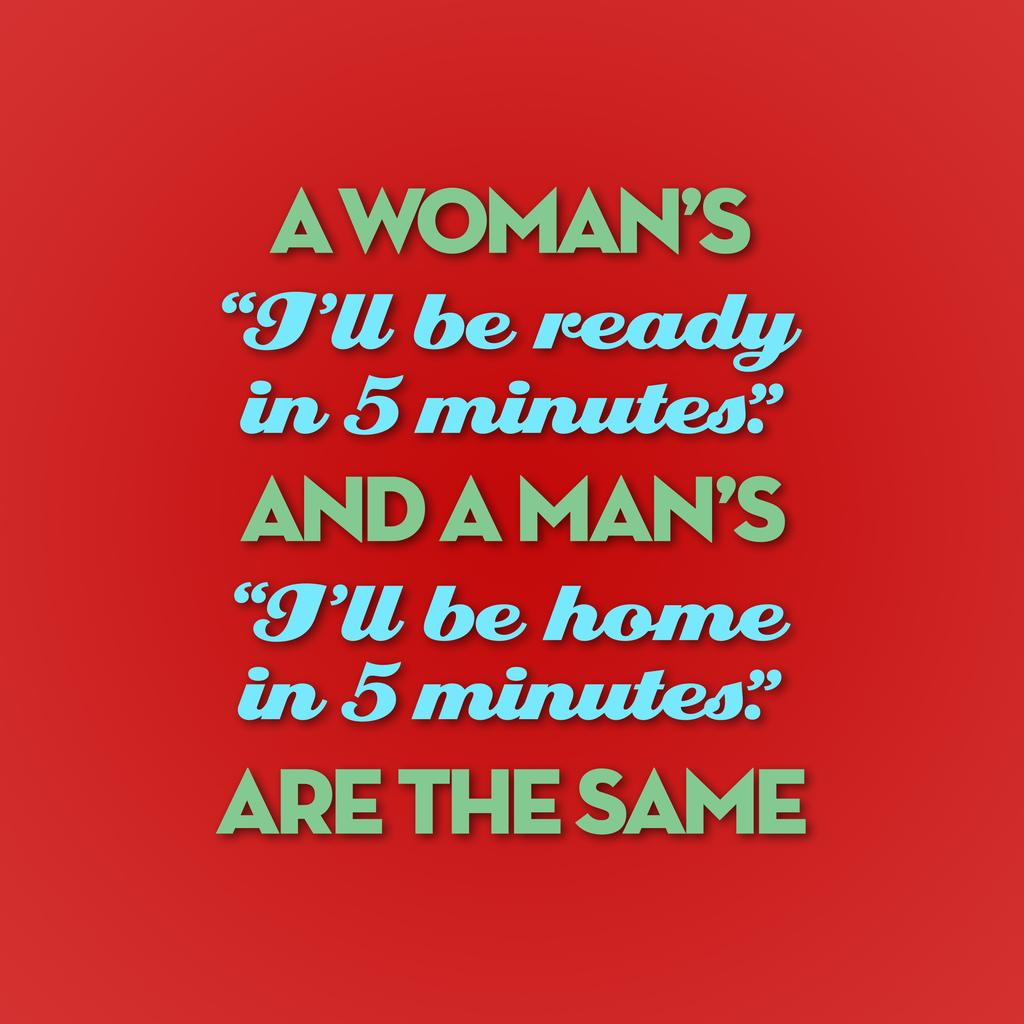<image>
Present a compact description of the photo's key features. A vibrant red poster with a humorous saying on it. 